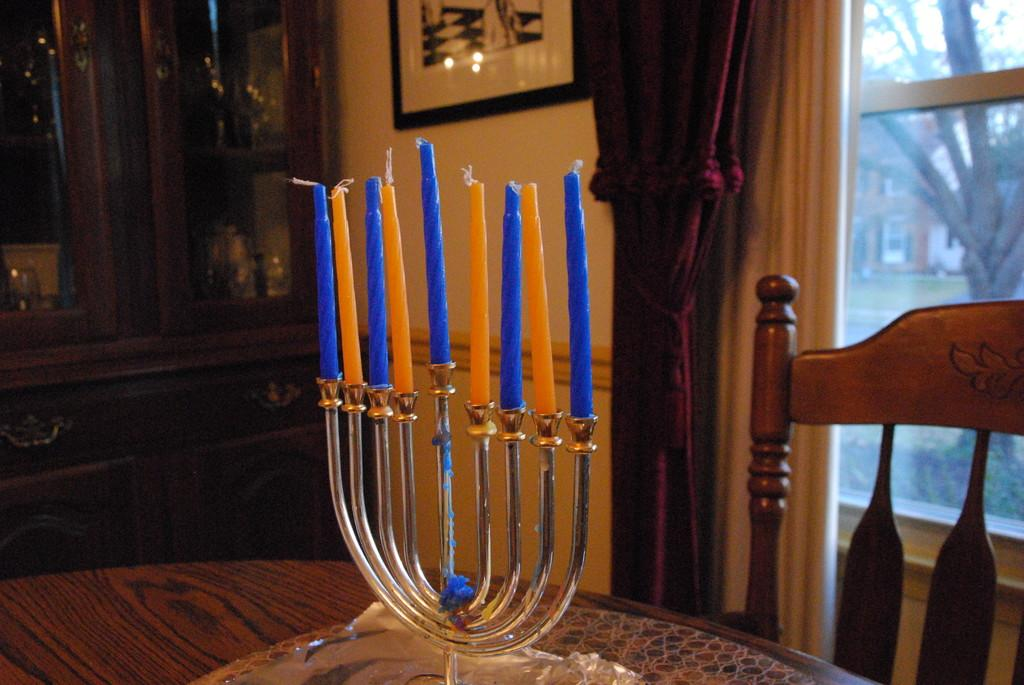What type of furniture is present in the image? There is a table, a chair, and a cupboard in the image. What is on the table in the image? There is a stand on the table in the image. What can be seen through the window in the image? There is a window in the image, and a curtain is associated with it. Where is the photo frame located in the image? The photo frame is on the wall in the image. What type of knee injury can be seen in the image? There is no knee injury present in the image. Is there a tub visible in the image? No, there is no tub present in the image. 